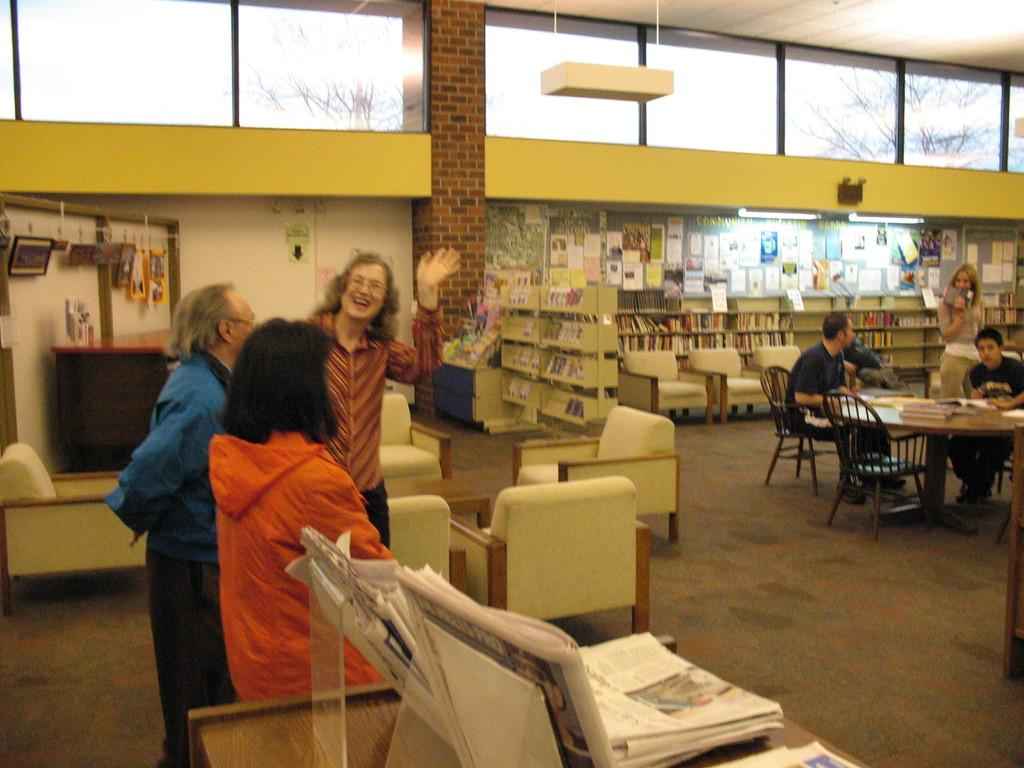How many persons are standing on the left side of the image? There are three persons standing on the left side of the image. What are the other persons doing in the image? The other persons are standing on chairs on the right side of the image. What can be seen in the background of the image? There is a bookshelf in the image. What is the source of light in the image? There is a light in the image. Can you see any tigers or cows in the image? No, there are no tigers or cows present in the image. Is there an oven visible in the image? No, there is no oven present in the image. 